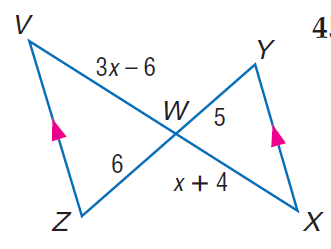Answer the mathemtical geometry problem and directly provide the correct option letter.
Question: Find x.
Choices: A: 6 B: 8 C: 10 D: 12 A 